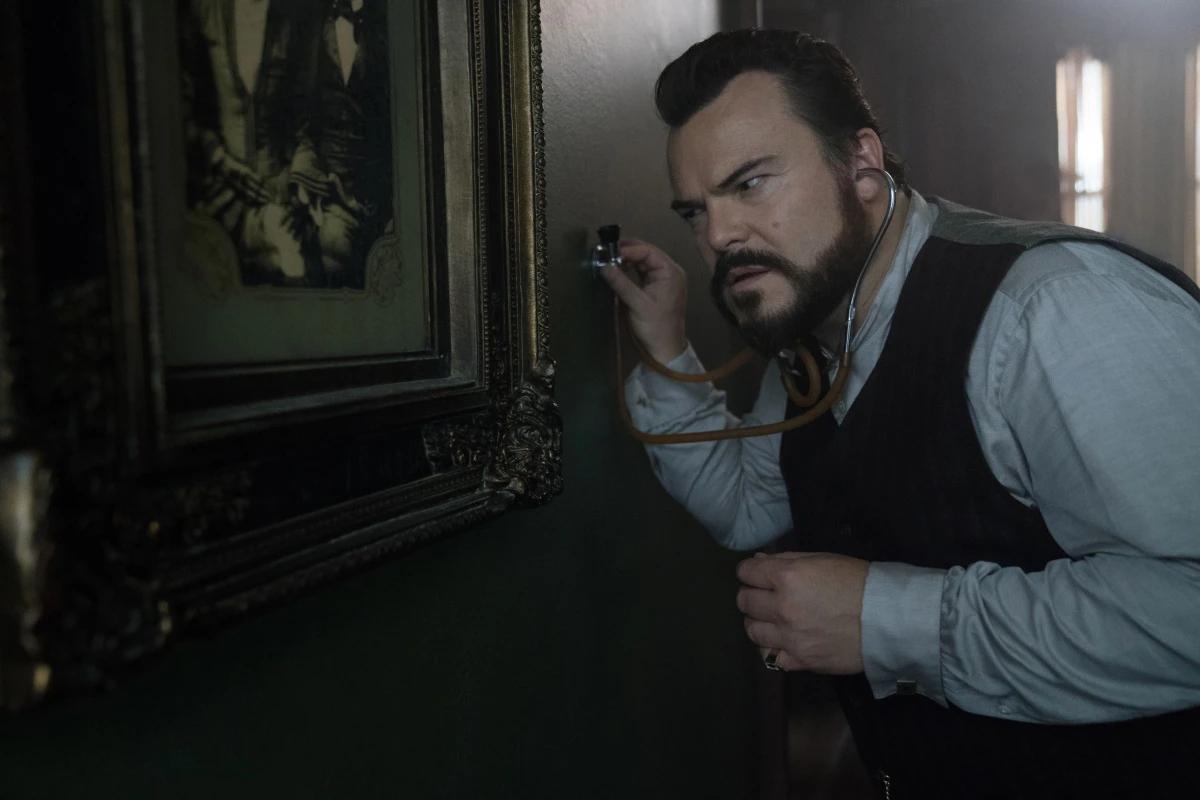What might be a realistic scenario in this image? In a realistic scenario, the man in the image could be a private investigator or a detective working on a case. He may have received a tip that the painting conceals a safe or hidden compartment. Using the stethoscope, he attempts to listen for any mechanical clicks or movements indicating the presence of a hidden lock mechanism. His serious demeanor reflects the gravity of the situation, as he might be on the verge of uncovering crucial evidence related to the case he's working on. The dimly lit setting emphasizes the secrecy and importance of his task. What do you think the painting depicts in this realistic scenario? The painting likely depicts two prominent figures from an earlier era, possibly related to the case the investigator is working on. It might be a family heirloom or a piece of historical significance that links back to the investigation. The formal attire of the individuals in the painting suggests they were people of importance, and their connection to the current mystery could hold the key to unraveling the investigator's case. 